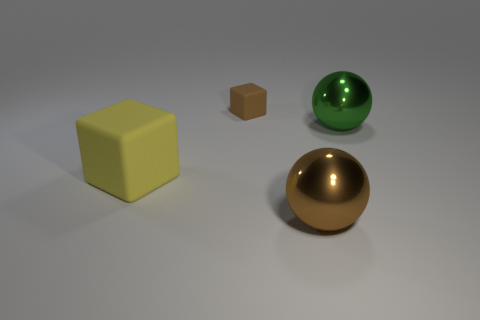Add 1 small matte cubes. How many objects exist? 5 Subtract 1 brown cubes. How many objects are left? 3 Subtract all tiny brown balls. Subtract all big objects. How many objects are left? 1 Add 3 metal balls. How many metal balls are left? 5 Add 3 tiny things. How many tiny things exist? 4 